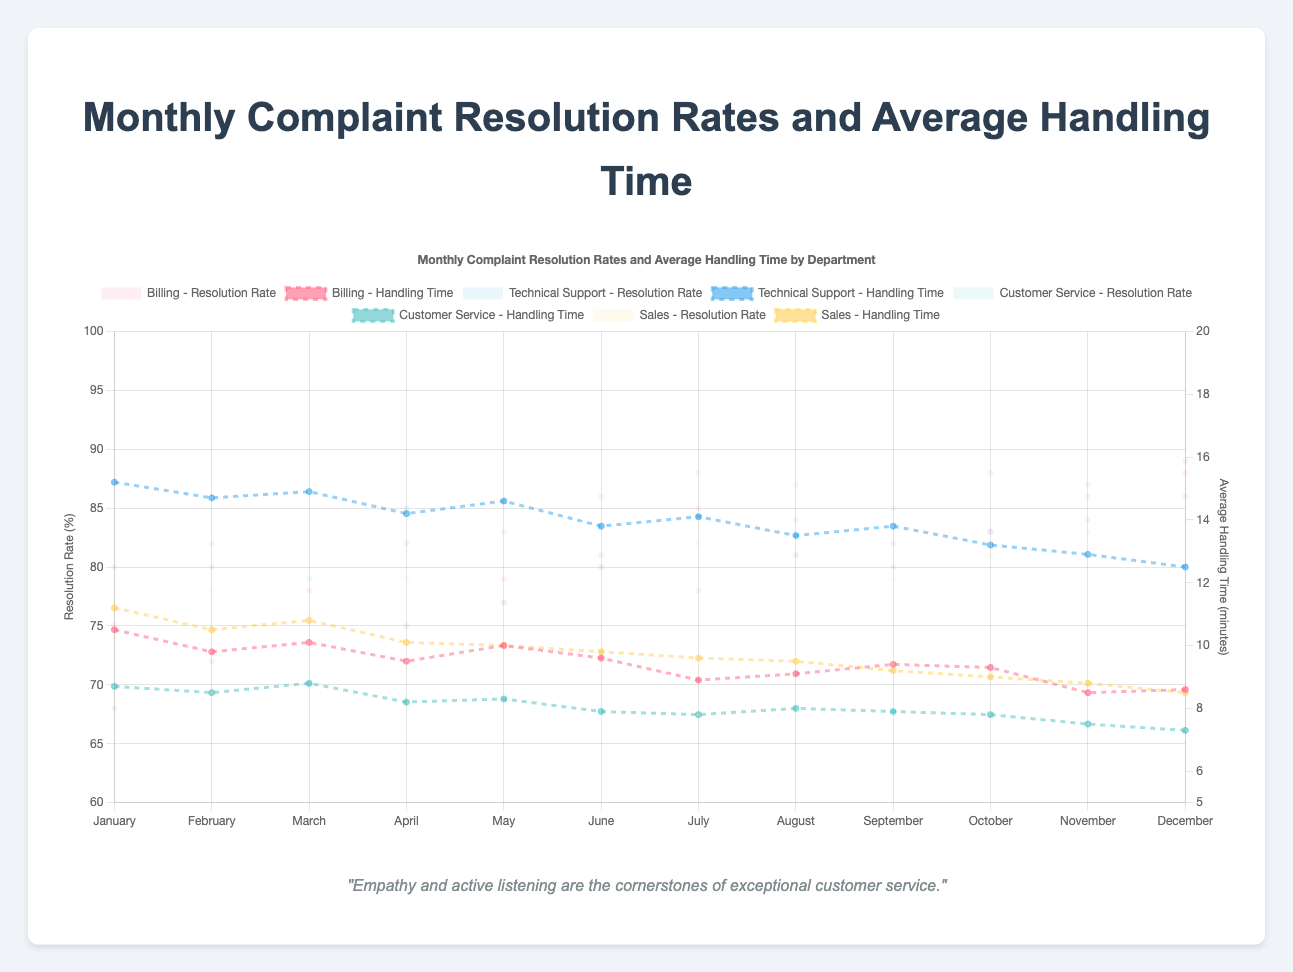What month had the highest complaint resolution rate for the Customer Service department? The Customer Service department's complaint resolution rate is highest in December, as indicated by the peak point on the graph at 89%.
Answer: December How does the average handling time for Technical Support in July compare to that in December? In July, the average handling time for Technical Support is around 14.1 minutes, and in December, it is 12.5 minutes. This indicates a reduction in handling time by 1.6 minutes from July to December.
Answer: December is lower Which department had the largest increase in resolution rate from January to December? For each department, calculate the difference in resolution rate between January and December: Billing (88-75=13), Technical Support (86-68=18), Customer Service (89-80=9), and Sales (84-74=10). Technical Support had the largest increase of 18%.
Answer: Technical Support What is the trend of monthly average handling time for the Billing department from January to December? The average handling time for the Billing department shows a declining trend from January (10.5 minutes) to December (8.6 minutes), indicating an improvement over time.
Answer: Declining Compare the average handling time of Technical Support and Customer Service in November. Which one is higher? In November, the average handling time for Technical Support is 12.9 minutes, while for Customer Service it is 7.5 minutes. Thus, Technical Support handles complaints in more time.
Answer: Technical Support is higher How did the complaint resolution rate for Sales change from January to June? For the Sales department, the resolution rate in January is 74 and in June it is 80. The rate increased by 6% over these months.
Answer: Increased Calculate the average complaint resolution rate for Billing over the entire year. Adding the resolution rates for Billing for each month: (75+80+78+82+79+81+85+84+82+83+86+88) and dividing by 12 gives the average: (993/12) ≈ 82.75%.
Answer: 82.75% Which department consistently had the lowest average handling time throughout the year? Comparing the annual average Handling times, Customer Service consistently maintains the lowest average handling time each month, ranging between 7.3 - 8.8 minutes.
Answer: Customer Service Which department experienced the greatest variability in average handling time throughout the year? By looking at the range of average handling times, Technical Support has the greatest variability, starting from 15.2 minutes in January to 12.5 minutes in December, a range of 2.7 minutes.
Answer: Technical Support 